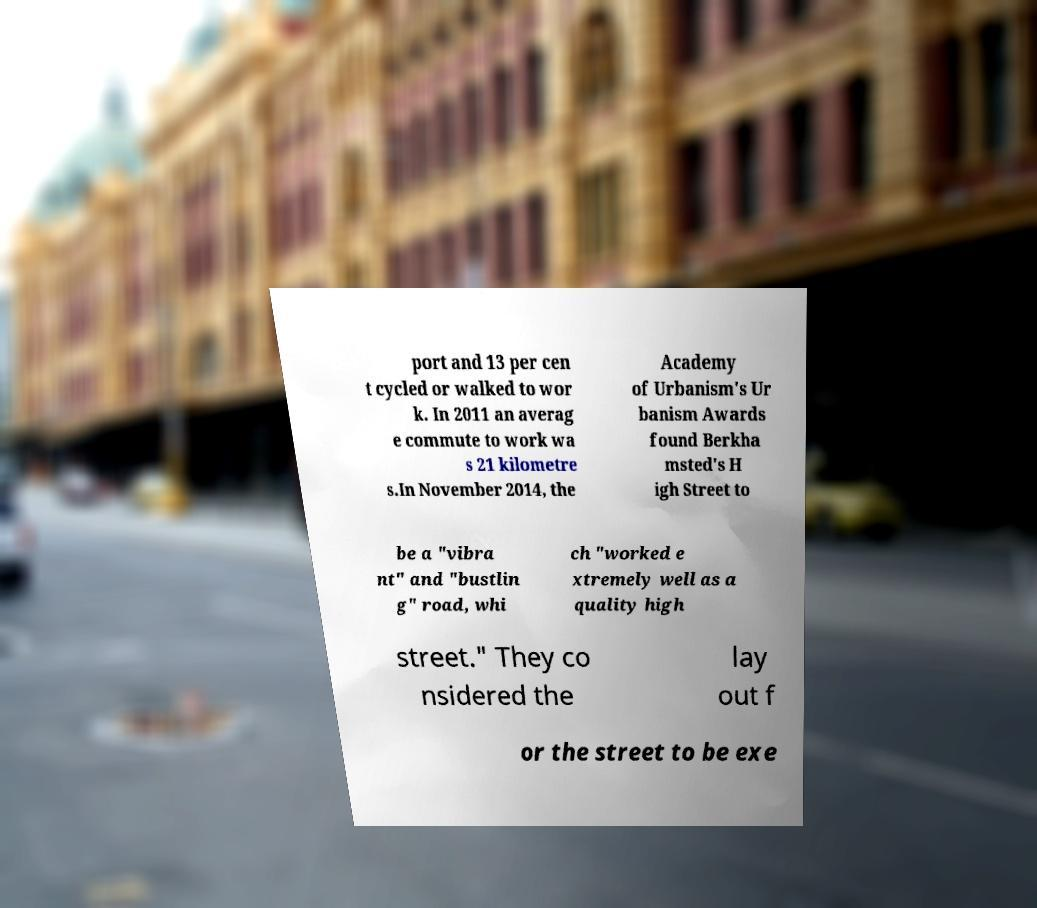Could you assist in decoding the text presented in this image and type it out clearly? port and 13 per cen t cycled or walked to wor k. In 2011 an averag e commute to work wa s 21 kilometre s.In November 2014, the Academy of Urbanism's Ur banism Awards found Berkha msted's H igh Street to be a "vibra nt" and "bustlin g" road, whi ch "worked e xtremely well as a quality high street." They co nsidered the lay out f or the street to be exe 